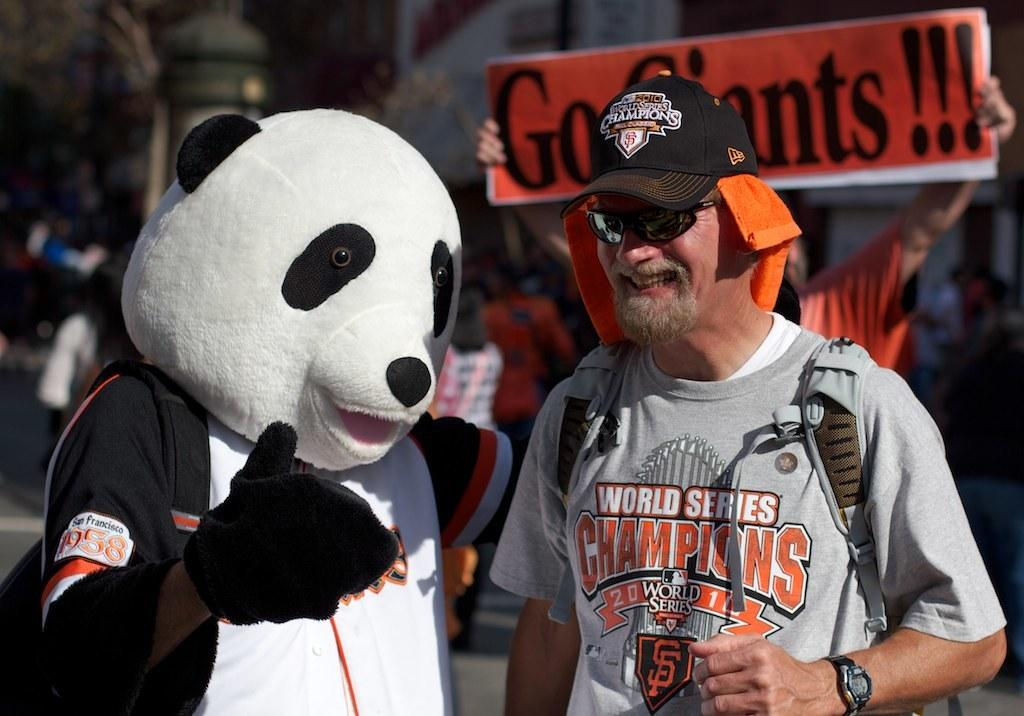<image>
Relay a brief, clear account of the picture shown. A man with World Series Champions on his shirt talking to a panda bear mascot 